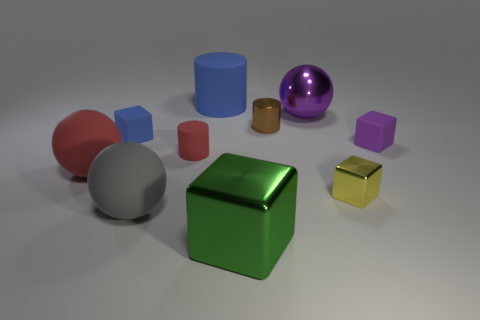What number of green metallic cylinders have the same size as the green metallic cube?
Offer a terse response. 0. What number of metal objects are tiny blue cubes or small red things?
Give a very brief answer. 0. What material is the big purple ball?
Offer a very short reply. Metal. There is a big red ball; how many brown objects are to the right of it?
Provide a succinct answer. 1. Are the tiny block left of the large purple ball and the big blue thing made of the same material?
Make the answer very short. Yes. How many big blue objects are the same shape as the small blue matte object?
Your response must be concise. 0. What number of tiny things are gray matte objects or red shiny objects?
Keep it short and to the point. 0. Is the color of the tiny matte block on the left side of the large green cube the same as the large rubber cylinder?
Offer a very short reply. Yes. There is a sphere behind the tiny blue block; is it the same color as the matte block in front of the small blue thing?
Keep it short and to the point. Yes. Are there any balls that have the same material as the large blue cylinder?
Your answer should be compact. Yes. 